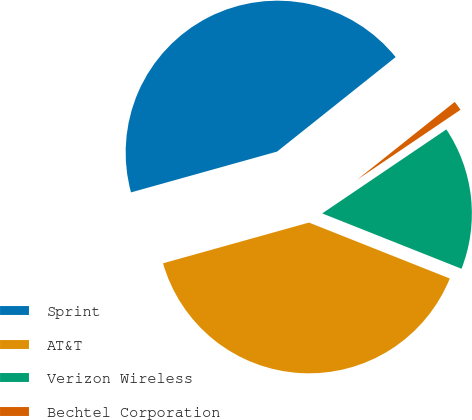Convert chart. <chart><loc_0><loc_0><loc_500><loc_500><pie_chart><fcel>Sprint<fcel>AT&T<fcel>Verizon Wireless<fcel>Bechtel Corporation<nl><fcel>43.63%<fcel>39.65%<fcel>15.49%<fcel>1.24%<nl></chart> 